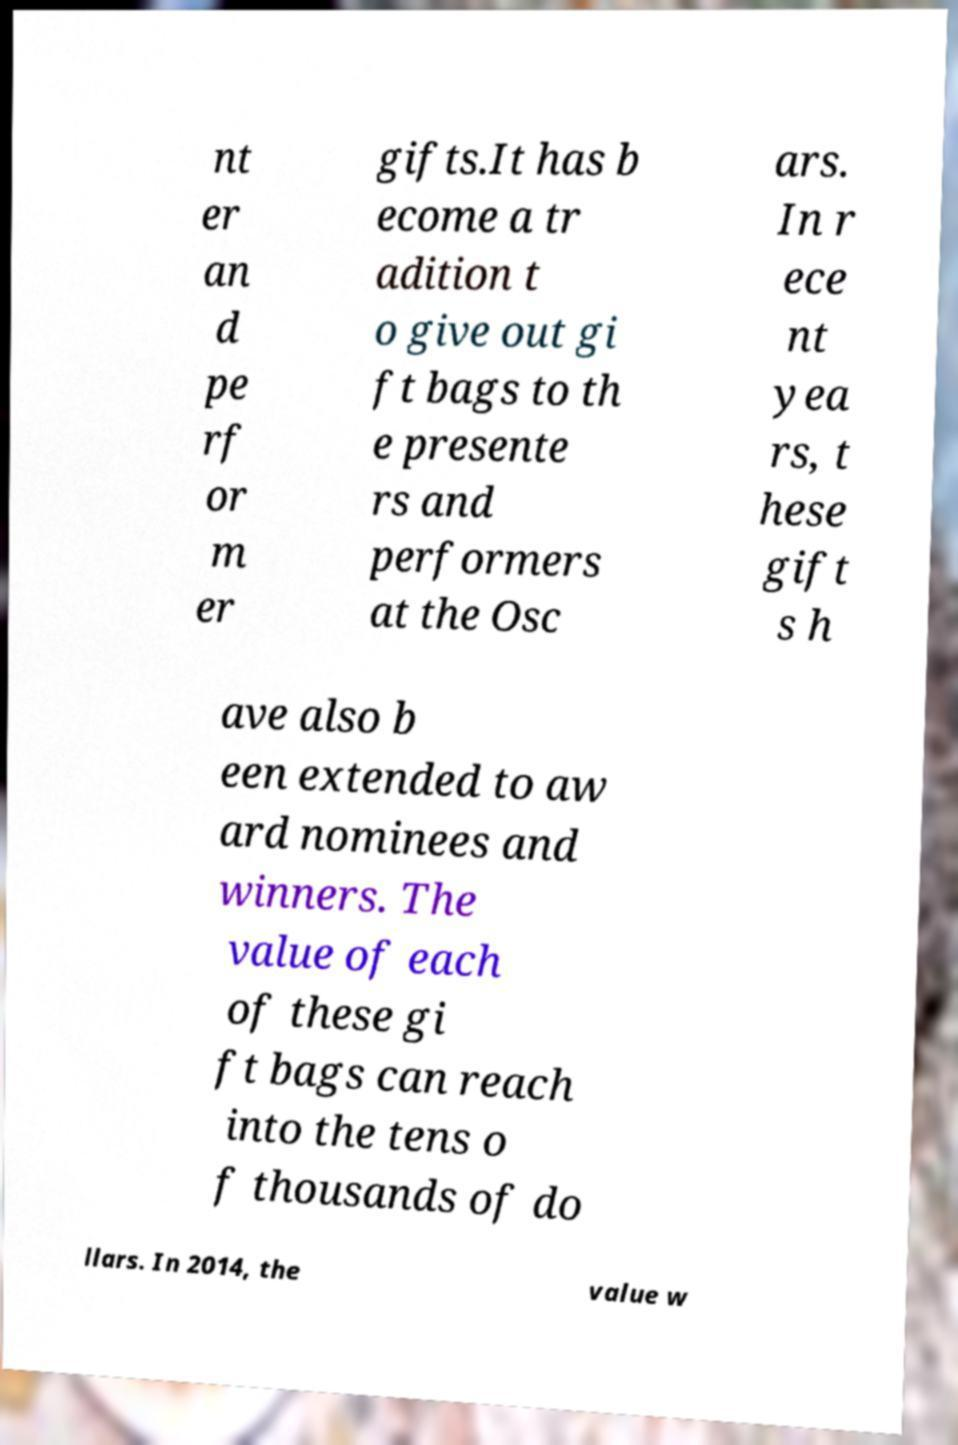Please identify and transcribe the text found in this image. nt er an d pe rf or m er gifts.It has b ecome a tr adition t o give out gi ft bags to th e presente rs and performers at the Osc ars. In r ece nt yea rs, t hese gift s h ave also b een extended to aw ard nominees and winners. The value of each of these gi ft bags can reach into the tens o f thousands of do llars. In 2014, the value w 